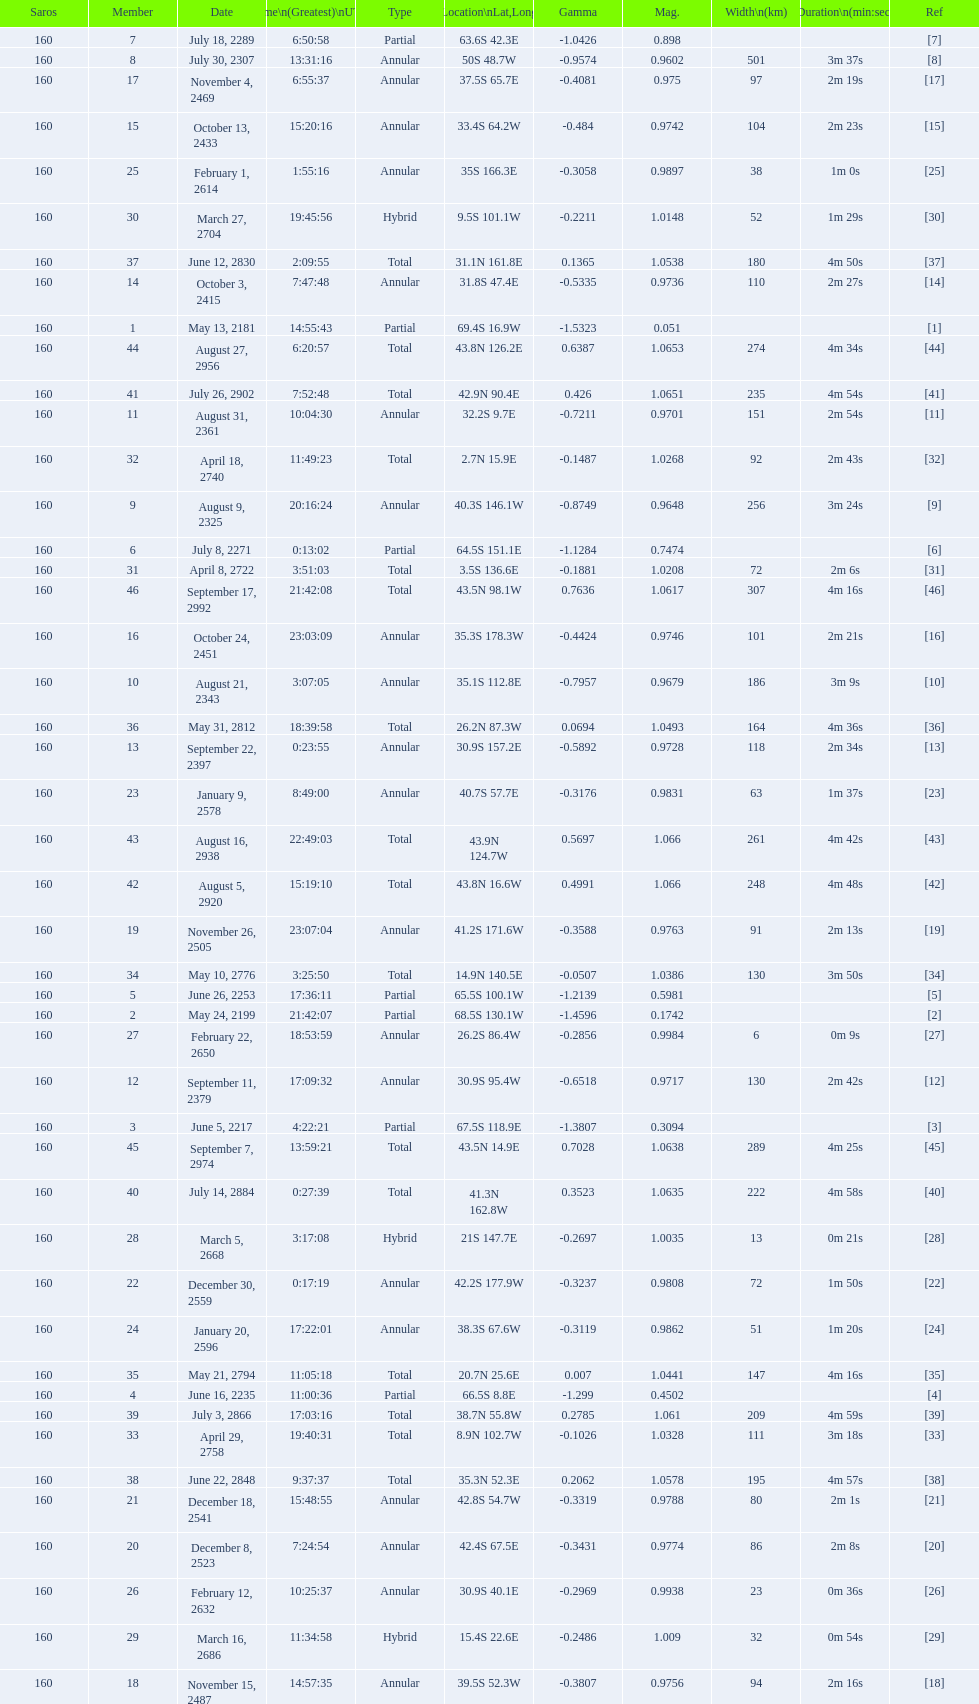Which one has a larger width, 8 or 21? 8. 